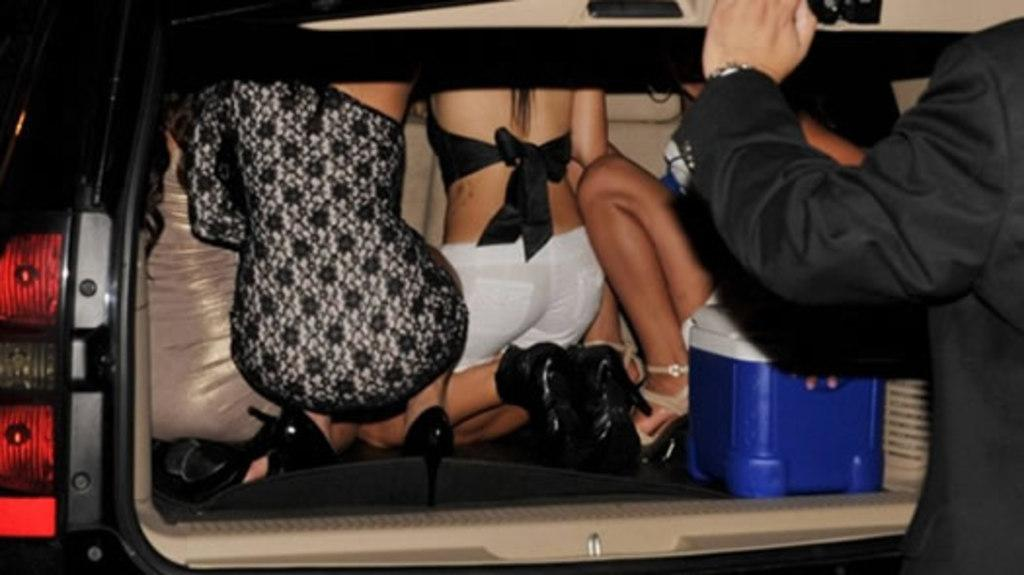What is happening in the image involving people? There are people in a vehicle in the image. What object can be seen in addition to the people in the vehicle? There is a box visible in the image. Can you describe the person on the right side of the image? There is a person standing on the right side of the image. What type of yam is being exchanged between the nerves in the image? There is no yam, exchange, or nerve present in the image. 